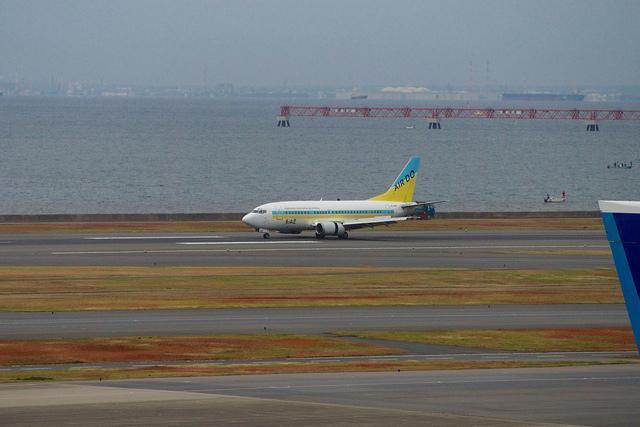The colors of this vehicle resemble which flag?
Select the accurate answer and provide justification: `Answer: choice
Rationale: srationale.`
Options: Belarus, russia, argentina, india. Answer: argentina.
Rationale: The plane has a white, blue, and yellow livery. the livery does not contain red, orange, or green. 